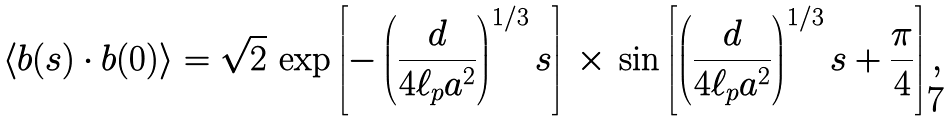Convert formula to latex. <formula><loc_0><loc_0><loc_500><loc_500>\left < { b } ( s ) \cdot { b } ( 0 ) \right > = \sqrt { 2 } \, \exp \left [ - \left ( \frac { d } { 4 \ell _ { p } a ^ { 2 } } \right ) ^ { 1 / 3 } s \right ] \, \times \, \sin \left [ \left ( \frac { d } { 4 \ell _ { p } a ^ { 2 } } \right ) ^ { 1 / 3 } s + \frac { \pi } { 4 } \right ] ,</formula> 